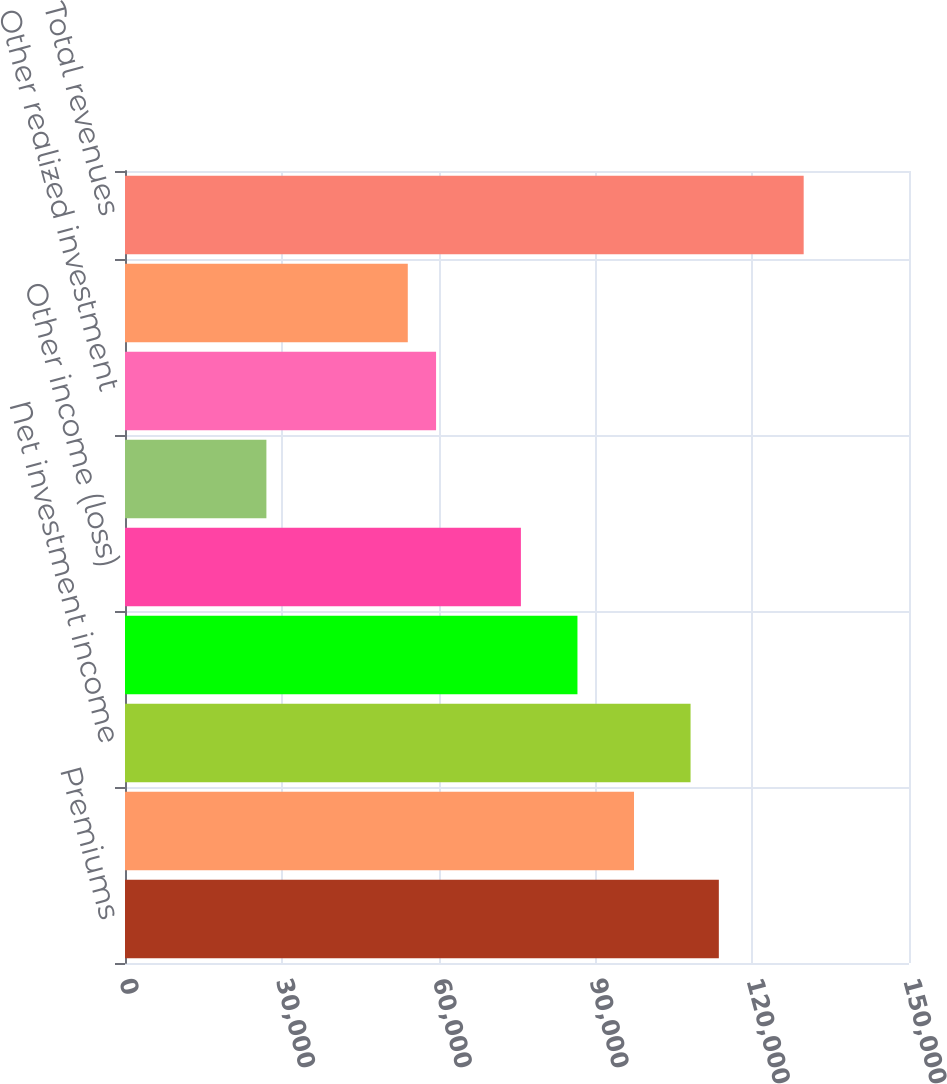<chart> <loc_0><loc_0><loc_500><loc_500><bar_chart><fcel>Premiums<fcel>Policy charges and fee income<fcel>Net investment income<fcel>Asset management and service<fcel>Other income (loss)<fcel>Other-than-temporary<fcel>Other realized investment<fcel>Total realized investment<fcel>Total revenues<nl><fcel>113618<fcel>97387.2<fcel>108208<fcel>86566.6<fcel>75746.1<fcel>27053.6<fcel>59515.2<fcel>54105<fcel>129849<nl></chart> 